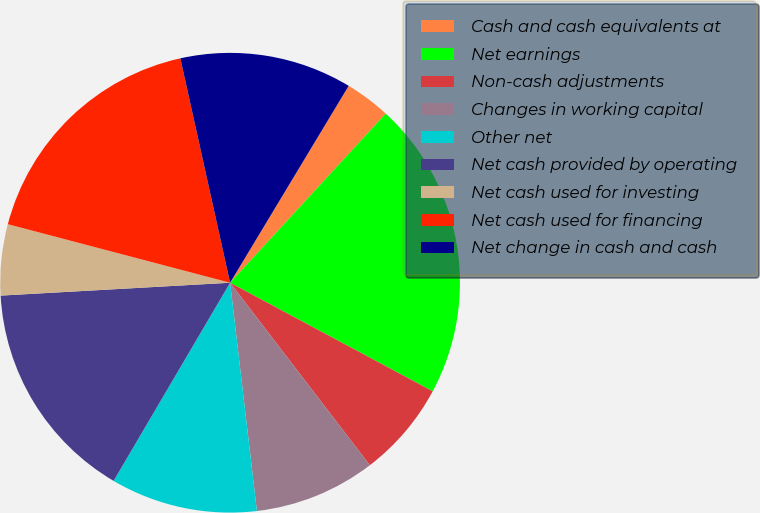Convert chart. <chart><loc_0><loc_0><loc_500><loc_500><pie_chart><fcel>Cash and cash equivalents at<fcel>Net earnings<fcel>Non-cash adjustments<fcel>Changes in working capital<fcel>Other net<fcel>Net cash provided by operating<fcel>Net cash used for investing<fcel>Net cash used for financing<fcel>Net change in cash and cash<nl><fcel>3.21%<fcel>20.99%<fcel>6.77%<fcel>8.54%<fcel>10.32%<fcel>15.65%<fcel>4.99%<fcel>17.43%<fcel>12.1%<nl></chart> 